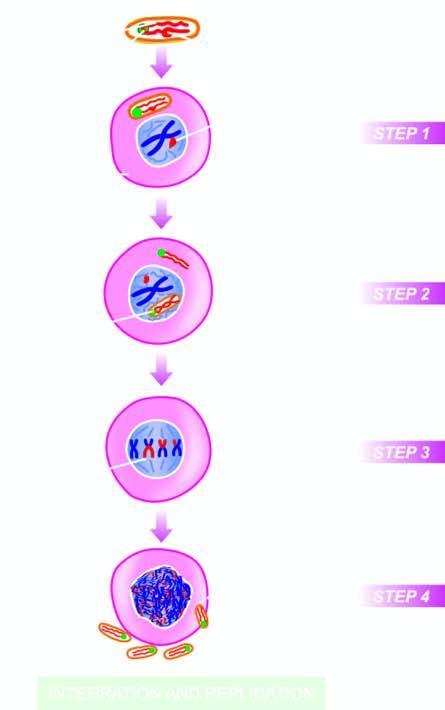does necrosis fuse with the plasma membrane of the host cell?
Answer the question using a single word or phrase. No 